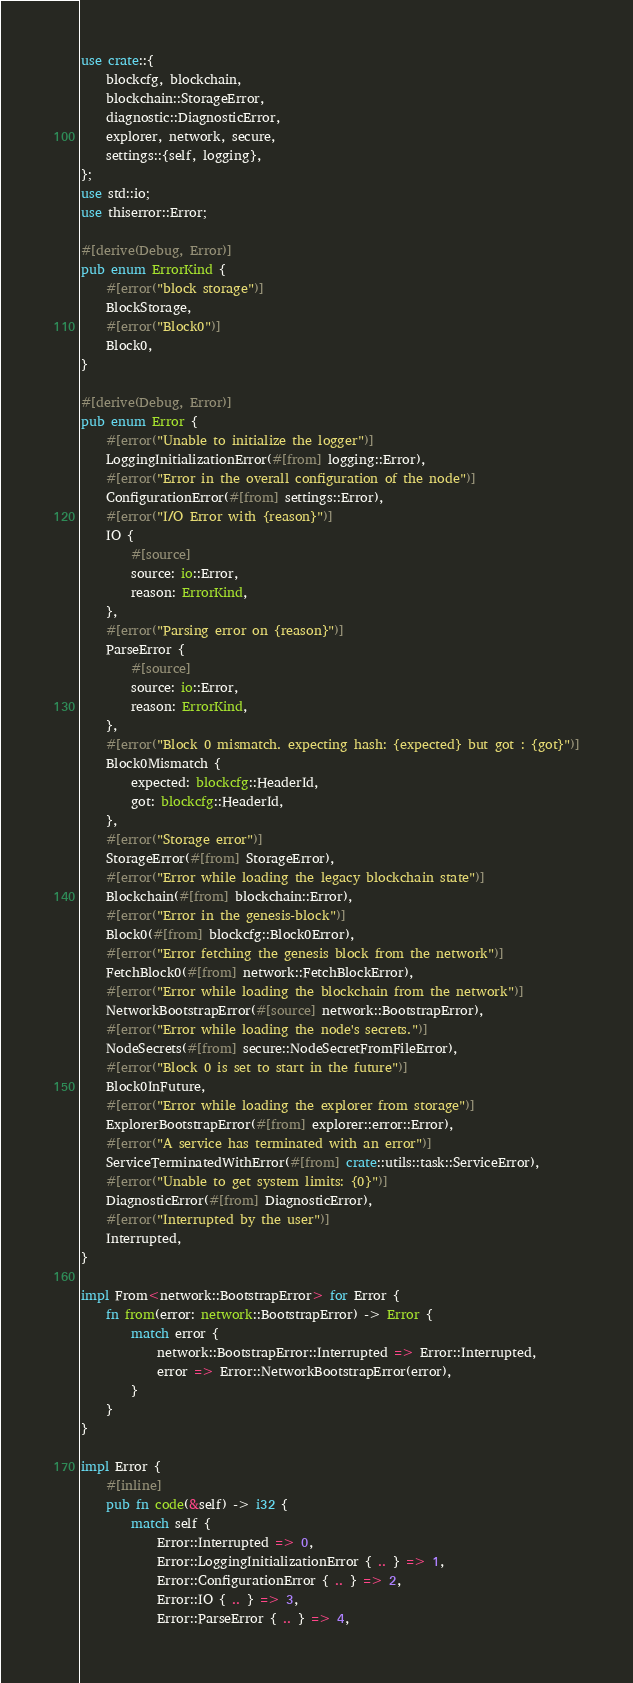<code> <loc_0><loc_0><loc_500><loc_500><_Rust_>use crate::{
    blockcfg, blockchain,
    blockchain::StorageError,
    diagnostic::DiagnosticError,
    explorer, network, secure,
    settings::{self, logging},
};
use std::io;
use thiserror::Error;

#[derive(Debug, Error)]
pub enum ErrorKind {
    #[error("block storage")]
    BlockStorage,
    #[error("Block0")]
    Block0,
}

#[derive(Debug, Error)]
pub enum Error {
    #[error("Unable to initialize the logger")]
    LoggingInitializationError(#[from] logging::Error),
    #[error("Error in the overall configuration of the node")]
    ConfigurationError(#[from] settings::Error),
    #[error("I/O Error with {reason}")]
    IO {
        #[source]
        source: io::Error,
        reason: ErrorKind,
    },
    #[error("Parsing error on {reason}")]
    ParseError {
        #[source]
        source: io::Error,
        reason: ErrorKind,
    },
    #[error("Block 0 mismatch. expecting hash: {expected} but got : {got}")]
    Block0Mismatch {
        expected: blockcfg::HeaderId,
        got: blockcfg::HeaderId,
    },
    #[error("Storage error")]
    StorageError(#[from] StorageError),
    #[error("Error while loading the legacy blockchain state")]
    Blockchain(#[from] blockchain::Error),
    #[error("Error in the genesis-block")]
    Block0(#[from] blockcfg::Block0Error),
    #[error("Error fetching the genesis block from the network")]
    FetchBlock0(#[from] network::FetchBlockError),
    #[error("Error while loading the blockchain from the network")]
    NetworkBootstrapError(#[source] network::BootstrapError),
    #[error("Error while loading the node's secrets.")]
    NodeSecrets(#[from] secure::NodeSecretFromFileError),
    #[error("Block 0 is set to start in the future")]
    Block0InFuture,
    #[error("Error while loading the explorer from storage")]
    ExplorerBootstrapError(#[from] explorer::error::Error),
    #[error("A service has terminated with an error")]
    ServiceTerminatedWithError(#[from] crate::utils::task::ServiceError),
    #[error("Unable to get system limits: {0}")]
    DiagnosticError(#[from] DiagnosticError),
    #[error("Interrupted by the user")]
    Interrupted,
}

impl From<network::BootstrapError> for Error {
    fn from(error: network::BootstrapError) -> Error {
        match error {
            network::BootstrapError::Interrupted => Error::Interrupted,
            error => Error::NetworkBootstrapError(error),
        }
    }
}

impl Error {
    #[inline]
    pub fn code(&self) -> i32 {
        match self {
            Error::Interrupted => 0,
            Error::LoggingInitializationError { .. } => 1,
            Error::ConfigurationError { .. } => 2,
            Error::IO { .. } => 3,
            Error::ParseError { .. } => 4,</code> 